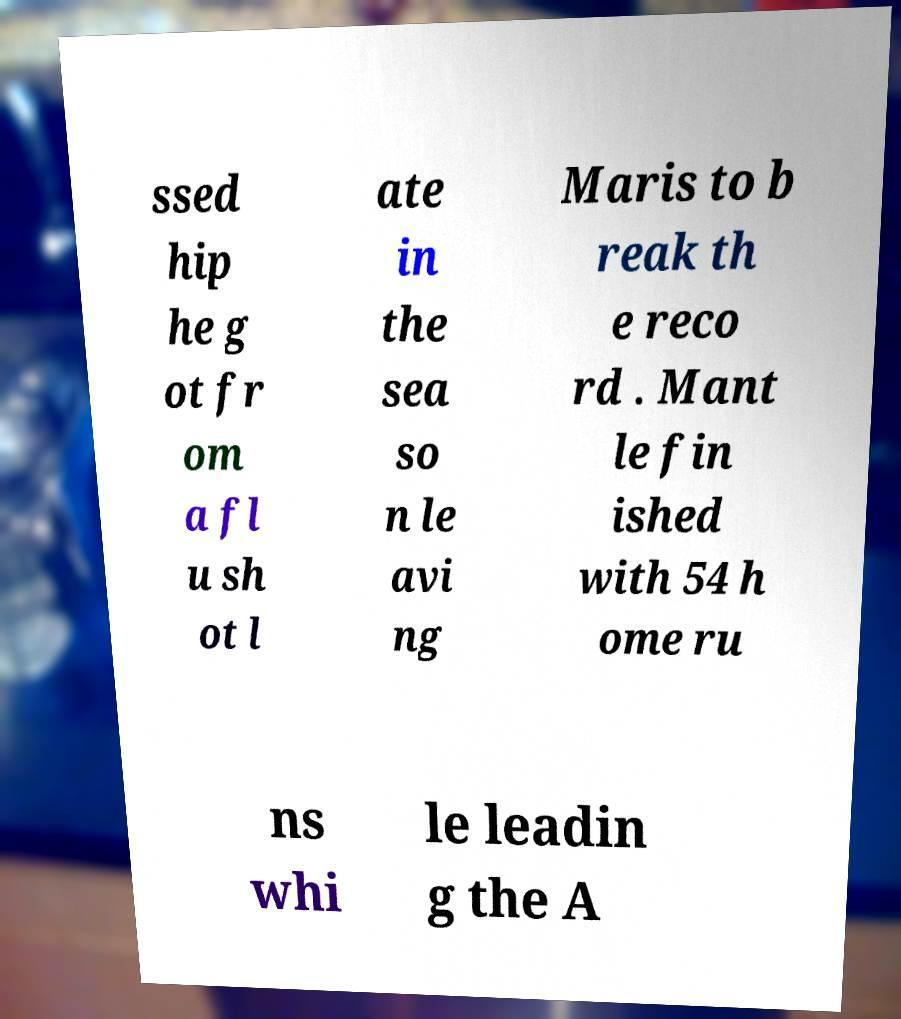What messages or text are displayed in this image? I need them in a readable, typed format. ssed hip he g ot fr om a fl u sh ot l ate in the sea so n le avi ng Maris to b reak th e reco rd . Mant le fin ished with 54 h ome ru ns whi le leadin g the A 